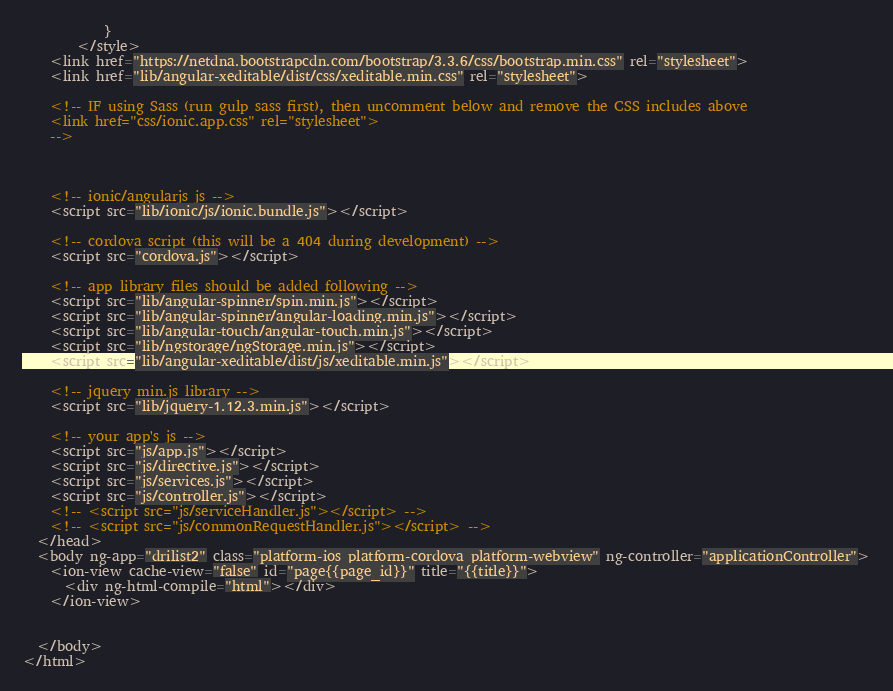<code> <loc_0><loc_0><loc_500><loc_500><_HTML_>			}
		</style>
    <link href="https://netdna.bootstrapcdn.com/bootstrap/3.3.6/css/bootstrap.min.css" rel="stylesheet">
    <link href="lib/angular-xeditable/dist/css/xeditable.min.css" rel="stylesheet">

    <!-- IF using Sass (run gulp sass first), then uncomment below and remove the CSS includes above
    <link href="css/ionic.app.css" rel="stylesheet">
    -->

    

    <!-- ionic/angularjs js -->
    <script src="lib/ionic/js/ionic.bundle.js"></script>

    <!-- cordova script (this will be a 404 during development) -->
    <script src="cordova.js"></script>

    <!-- app library files should be added following -->
    <script src="lib/angular-spinner/spin.min.js"></script>
    <script src="lib/angular-spinner/angular-loading.min.js"></script>
    <script src="lib/angular-touch/angular-touch.min.js"></script>
    <script src="lib/ngstorage/ngStorage.min.js"></script>
    <script src="lib/angular-xeditable/dist/js/xeditable.min.js"></script>

    <!-- jquery min.js library -->
    <script src="lib/jquery-1.12.3.min.js"></script>

    <!-- your app's js -->
    <script src="js/app.js"></script>
    <script src="js/directive.js"></script>
    <script src="js/services.js"></script>
    <script src="js/controller.js"></script>
    <!-- <script src="js/serviceHandler.js"></script> -->
    <!-- <script src="js/commonRequestHandler.js"></script> -->
  </head>
  <body ng-app="drilist2" class="platform-ios platform-cordova platform-webview" ng-controller="applicationController">
    <ion-view cache-view="false" id="page{{page_id}}" title="{{title}}">
      <div ng-html-compile="html"></div>
    </ion-view>


  </body>
</html>
</code> 